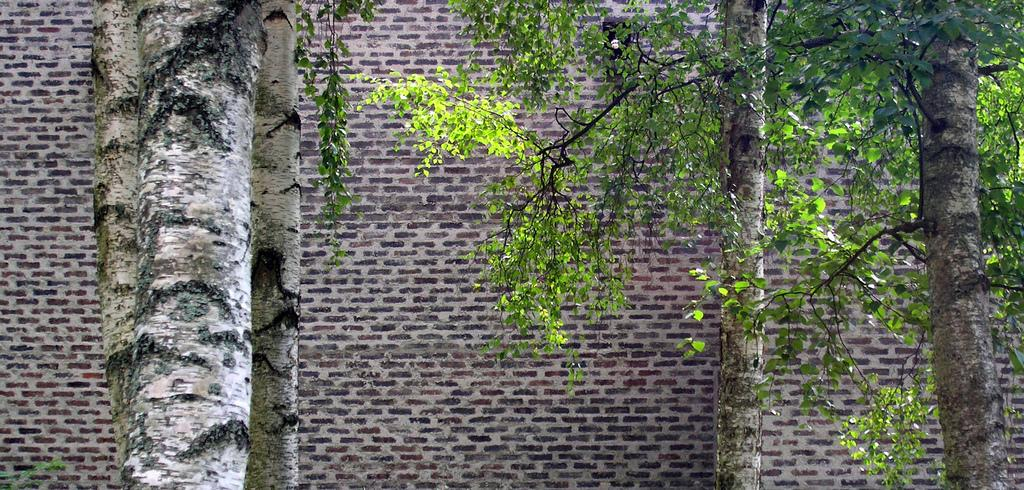What type of vegetation is in the foreground of the image? There are trees in the foreground of the image. What type of structure is in the background of the image? There is a brick wall in the background of the image. What type of quartz can be seen embedded in the brick wall in the image? There is no quartz present in the image, and the brick wall does not appear to have any embedded materials. How does the ray of light affect the appearance of the trees in the image? There is no mention of a ray of light in the image, so we cannot comment on its effect on the trees. 